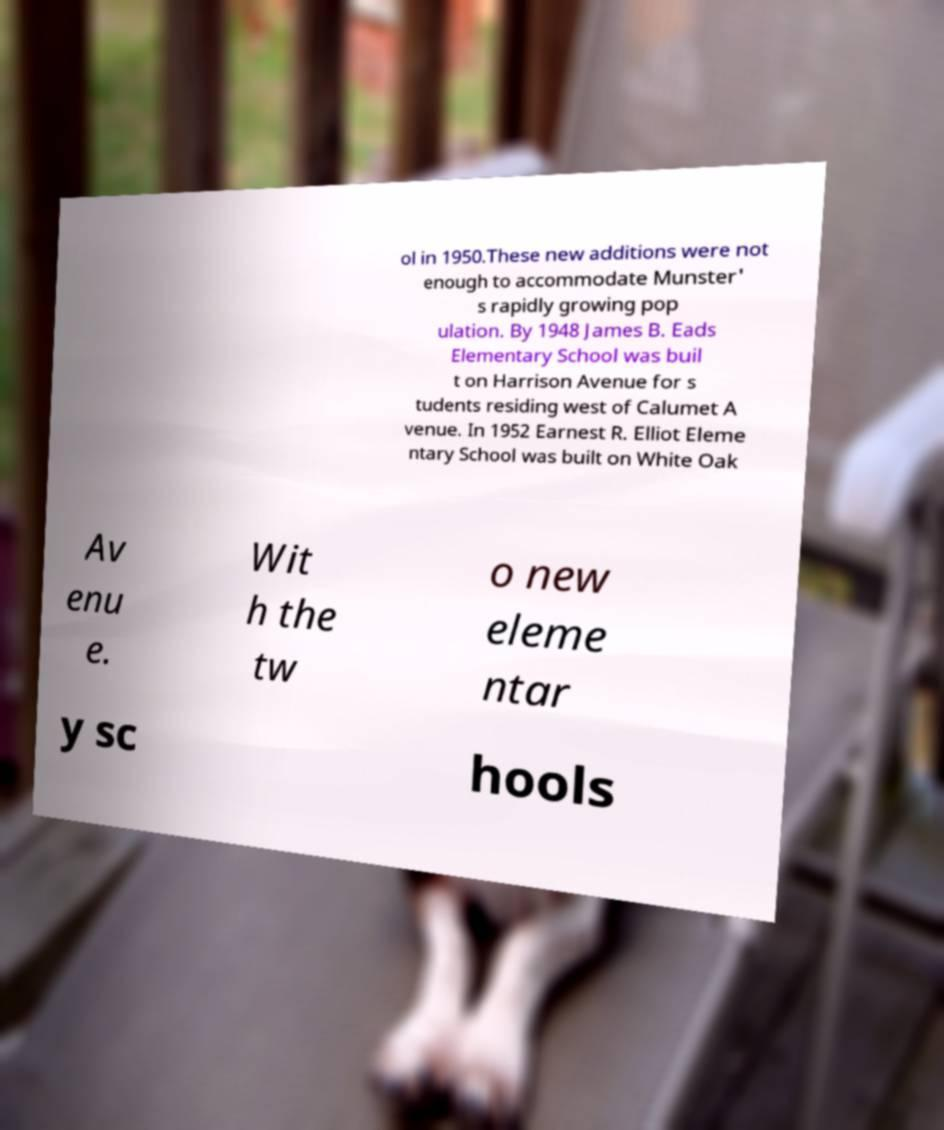Could you assist in decoding the text presented in this image and type it out clearly? ol in 1950.These new additions were not enough to accommodate Munster' s rapidly growing pop ulation. By 1948 James B. Eads Elementary School was buil t on Harrison Avenue for s tudents residing west of Calumet A venue. In 1952 Earnest R. Elliot Eleme ntary School was built on White Oak Av enu e. Wit h the tw o new eleme ntar y sc hools 